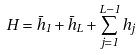Convert formula to latex. <formula><loc_0><loc_0><loc_500><loc_500>H = { \bar { h } _ { 1 } } + { \bar { h } _ { L } } + \sum _ { j = 1 } ^ { L - 1 } h _ { j }</formula> 